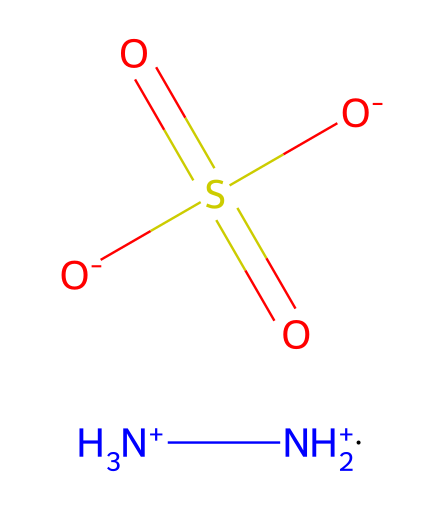What is the total number of nitrogen atoms in hydrazine sulfate? The chemical structure contains two nitrogen atoms, as indicated by the [NH3+] and [NH2+] groups. Counting both gives a total of two nitrogen atoms.
Answer: two How many oxygen atoms are present in the structure? The sulfate group [O-]S(=O)(=O)[O-] indicates three oxygen atoms bonded to the sulfur atom. Thus, there are three oxygen atoms in total.
Answer: three What type of bonds are present in hydrazine sulfate? The chemical contains covalent bonds primarily between nitrogen, oxygen, and sulfur atoms, as is typical for small organic molecules and functional groups like amines and sulfates.
Answer: covalent What functional groups are represented in hydrazine sulfate? The structure contains an amine group indicated by [NH3+] and [NH2+], and a sulfate group indicated by [O-]S(=O)(=O)[O-]. These represent the functional groups present in the compound.
Answer: amine and sulfate Is hydrazine sulfate an acid or a base? The presence of amine groups, which are basic in nature, suggests that hydrazine sulfate has basic characteristics, but it also contains the sulfate group, which can exhibit acidic properties. Overall, it acts as a weak base.
Answer: weak base How many sulfur atoms are found in hydrazine sulfate? The structural representation shows only one sulfur atom at the center of the sulfate group [O-]S(=O)(=O)[O-]. This indicates that there is only one sulfur atom present in the chemical structure.
Answer: one 